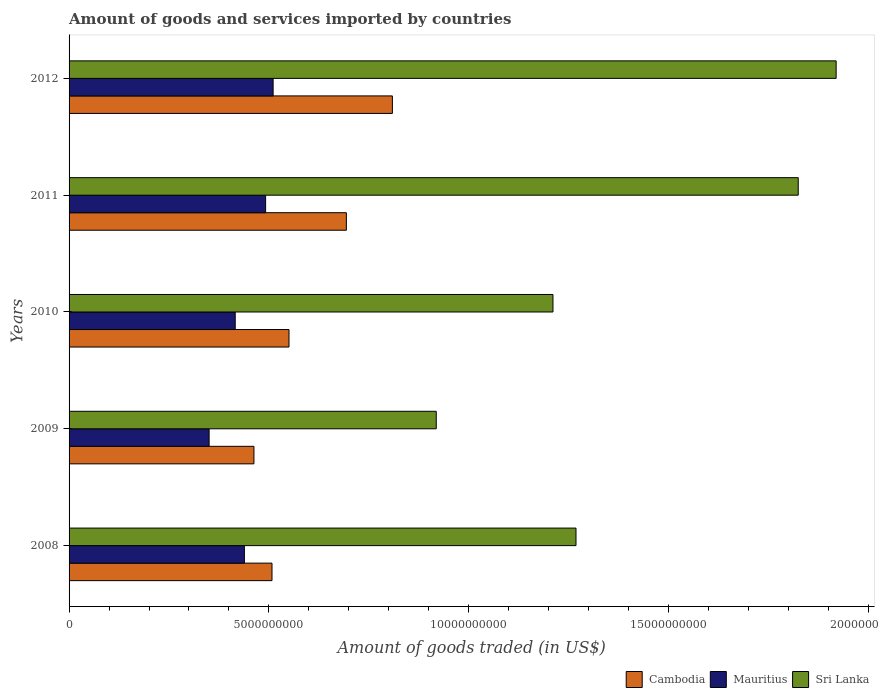How many different coloured bars are there?
Your answer should be very brief. 3. How many groups of bars are there?
Ensure brevity in your answer.  5. Are the number of bars per tick equal to the number of legend labels?
Provide a short and direct response. Yes. How many bars are there on the 5th tick from the bottom?
Keep it short and to the point. 3. What is the label of the 4th group of bars from the top?
Offer a terse response. 2009. What is the total amount of goods and services imported in Cambodia in 2012?
Provide a short and direct response. 8.09e+09. Across all years, what is the maximum total amount of goods and services imported in Mauritius?
Give a very brief answer. 5.10e+09. Across all years, what is the minimum total amount of goods and services imported in Sri Lanka?
Offer a terse response. 9.19e+09. In which year was the total amount of goods and services imported in Sri Lanka maximum?
Ensure brevity in your answer.  2012. What is the total total amount of goods and services imported in Sri Lanka in the graph?
Provide a succinct answer. 7.14e+1. What is the difference between the total amount of goods and services imported in Mauritius in 2009 and that in 2012?
Offer a terse response. -1.60e+09. What is the difference between the total amount of goods and services imported in Cambodia in 2009 and the total amount of goods and services imported in Mauritius in 2011?
Ensure brevity in your answer.  -2.93e+08. What is the average total amount of goods and services imported in Cambodia per year?
Make the answer very short. 6.05e+09. In the year 2011, what is the difference between the total amount of goods and services imported in Cambodia and total amount of goods and services imported in Mauritius?
Keep it short and to the point. 2.02e+09. In how many years, is the total amount of goods and services imported in Sri Lanka greater than 18000000000 US$?
Provide a short and direct response. 2. What is the ratio of the total amount of goods and services imported in Sri Lanka in 2011 to that in 2012?
Your answer should be very brief. 0.95. Is the total amount of goods and services imported in Sri Lanka in 2010 less than that in 2011?
Your response must be concise. Yes. What is the difference between the highest and the second highest total amount of goods and services imported in Mauritius?
Give a very brief answer. 1.87e+08. What is the difference between the highest and the lowest total amount of goods and services imported in Cambodia?
Make the answer very short. 3.46e+09. What does the 2nd bar from the top in 2008 represents?
Give a very brief answer. Mauritius. What does the 1st bar from the bottom in 2009 represents?
Provide a succinct answer. Cambodia. Is it the case that in every year, the sum of the total amount of goods and services imported in Mauritius and total amount of goods and services imported in Cambodia is greater than the total amount of goods and services imported in Sri Lanka?
Your response must be concise. No. How many bars are there?
Give a very brief answer. 15. How many years are there in the graph?
Provide a succinct answer. 5. Where does the legend appear in the graph?
Make the answer very short. Bottom right. How many legend labels are there?
Your answer should be compact. 3. How are the legend labels stacked?
Your answer should be compact. Horizontal. What is the title of the graph?
Your response must be concise. Amount of goods and services imported by countries. What is the label or title of the X-axis?
Ensure brevity in your answer.  Amount of goods traded (in US$). What is the Amount of goods traded (in US$) of Cambodia in 2008?
Provide a succinct answer. 5.08e+09. What is the Amount of goods traded (in US$) in Mauritius in 2008?
Your answer should be compact. 4.39e+09. What is the Amount of goods traded (in US$) of Sri Lanka in 2008?
Keep it short and to the point. 1.27e+1. What is the Amount of goods traded (in US$) of Cambodia in 2009?
Give a very brief answer. 4.62e+09. What is the Amount of goods traded (in US$) of Mauritius in 2009?
Provide a succinct answer. 3.50e+09. What is the Amount of goods traded (in US$) in Sri Lanka in 2009?
Provide a succinct answer. 9.19e+09. What is the Amount of goods traded (in US$) in Cambodia in 2010?
Make the answer very short. 5.50e+09. What is the Amount of goods traded (in US$) of Mauritius in 2010?
Give a very brief answer. 4.16e+09. What is the Amount of goods traded (in US$) in Sri Lanka in 2010?
Your answer should be very brief. 1.21e+1. What is the Amount of goods traded (in US$) in Cambodia in 2011?
Keep it short and to the point. 6.94e+09. What is the Amount of goods traded (in US$) of Mauritius in 2011?
Keep it short and to the point. 4.92e+09. What is the Amount of goods traded (in US$) of Sri Lanka in 2011?
Your answer should be very brief. 1.82e+1. What is the Amount of goods traded (in US$) of Cambodia in 2012?
Give a very brief answer. 8.09e+09. What is the Amount of goods traded (in US$) of Mauritius in 2012?
Keep it short and to the point. 5.10e+09. What is the Amount of goods traded (in US$) in Sri Lanka in 2012?
Your response must be concise. 1.92e+1. Across all years, what is the maximum Amount of goods traded (in US$) in Cambodia?
Offer a very short reply. 8.09e+09. Across all years, what is the maximum Amount of goods traded (in US$) of Mauritius?
Provide a succinct answer. 5.10e+09. Across all years, what is the maximum Amount of goods traded (in US$) of Sri Lanka?
Make the answer very short. 1.92e+1. Across all years, what is the minimum Amount of goods traded (in US$) in Cambodia?
Offer a very short reply. 4.62e+09. Across all years, what is the minimum Amount of goods traded (in US$) of Mauritius?
Your response must be concise. 3.50e+09. Across all years, what is the minimum Amount of goods traded (in US$) in Sri Lanka?
Your response must be concise. 9.19e+09. What is the total Amount of goods traded (in US$) in Cambodia in the graph?
Provide a succinct answer. 3.02e+1. What is the total Amount of goods traded (in US$) in Mauritius in the graph?
Offer a terse response. 2.21e+1. What is the total Amount of goods traded (in US$) of Sri Lanka in the graph?
Keep it short and to the point. 7.14e+1. What is the difference between the Amount of goods traded (in US$) of Cambodia in 2008 and that in 2009?
Your response must be concise. 4.52e+08. What is the difference between the Amount of goods traded (in US$) in Mauritius in 2008 and that in 2009?
Your response must be concise. 8.82e+08. What is the difference between the Amount of goods traded (in US$) in Sri Lanka in 2008 and that in 2009?
Ensure brevity in your answer.  3.50e+09. What is the difference between the Amount of goods traded (in US$) in Cambodia in 2008 and that in 2010?
Keep it short and to the point. -4.25e+08. What is the difference between the Amount of goods traded (in US$) of Mauritius in 2008 and that in 2010?
Provide a short and direct response. 2.29e+08. What is the difference between the Amount of goods traded (in US$) in Sri Lanka in 2008 and that in 2010?
Give a very brief answer. 5.76e+08. What is the difference between the Amount of goods traded (in US$) in Cambodia in 2008 and that in 2011?
Ensure brevity in your answer.  -1.86e+09. What is the difference between the Amount of goods traded (in US$) of Mauritius in 2008 and that in 2011?
Provide a short and direct response. -5.31e+08. What is the difference between the Amount of goods traded (in US$) of Sri Lanka in 2008 and that in 2011?
Your answer should be very brief. -5.56e+09. What is the difference between the Amount of goods traded (in US$) in Cambodia in 2008 and that in 2012?
Your answer should be very brief. -3.01e+09. What is the difference between the Amount of goods traded (in US$) in Mauritius in 2008 and that in 2012?
Make the answer very short. -7.19e+08. What is the difference between the Amount of goods traded (in US$) in Sri Lanka in 2008 and that in 2012?
Make the answer very short. -6.51e+09. What is the difference between the Amount of goods traded (in US$) in Cambodia in 2009 and that in 2010?
Provide a succinct answer. -8.77e+08. What is the difference between the Amount of goods traded (in US$) in Mauritius in 2009 and that in 2010?
Offer a very short reply. -6.53e+08. What is the difference between the Amount of goods traded (in US$) of Sri Lanka in 2009 and that in 2010?
Provide a short and direct response. -2.92e+09. What is the difference between the Amount of goods traded (in US$) in Cambodia in 2009 and that in 2011?
Provide a succinct answer. -2.31e+09. What is the difference between the Amount of goods traded (in US$) in Mauritius in 2009 and that in 2011?
Offer a very short reply. -1.41e+09. What is the difference between the Amount of goods traded (in US$) of Sri Lanka in 2009 and that in 2011?
Offer a terse response. -9.06e+09. What is the difference between the Amount of goods traded (in US$) in Cambodia in 2009 and that in 2012?
Offer a terse response. -3.46e+09. What is the difference between the Amount of goods traded (in US$) of Mauritius in 2009 and that in 2012?
Offer a very short reply. -1.60e+09. What is the difference between the Amount of goods traded (in US$) in Sri Lanka in 2009 and that in 2012?
Your answer should be very brief. -1.00e+1. What is the difference between the Amount of goods traded (in US$) in Cambodia in 2010 and that in 2011?
Your response must be concise. -1.44e+09. What is the difference between the Amount of goods traded (in US$) in Mauritius in 2010 and that in 2011?
Your answer should be compact. -7.61e+08. What is the difference between the Amount of goods traded (in US$) in Sri Lanka in 2010 and that in 2011?
Give a very brief answer. -6.14e+09. What is the difference between the Amount of goods traded (in US$) of Cambodia in 2010 and that in 2012?
Give a very brief answer. -2.59e+09. What is the difference between the Amount of goods traded (in US$) in Mauritius in 2010 and that in 2012?
Your response must be concise. -9.48e+08. What is the difference between the Amount of goods traded (in US$) of Sri Lanka in 2010 and that in 2012?
Offer a terse response. -7.08e+09. What is the difference between the Amount of goods traded (in US$) in Cambodia in 2011 and that in 2012?
Offer a terse response. -1.15e+09. What is the difference between the Amount of goods traded (in US$) in Mauritius in 2011 and that in 2012?
Provide a succinct answer. -1.87e+08. What is the difference between the Amount of goods traded (in US$) of Sri Lanka in 2011 and that in 2012?
Provide a short and direct response. -9.48e+08. What is the difference between the Amount of goods traded (in US$) in Cambodia in 2008 and the Amount of goods traded (in US$) in Mauritius in 2009?
Make the answer very short. 1.57e+09. What is the difference between the Amount of goods traded (in US$) of Cambodia in 2008 and the Amount of goods traded (in US$) of Sri Lanka in 2009?
Ensure brevity in your answer.  -4.11e+09. What is the difference between the Amount of goods traded (in US$) in Mauritius in 2008 and the Amount of goods traded (in US$) in Sri Lanka in 2009?
Provide a short and direct response. -4.80e+09. What is the difference between the Amount of goods traded (in US$) of Cambodia in 2008 and the Amount of goods traded (in US$) of Mauritius in 2010?
Your answer should be compact. 9.20e+08. What is the difference between the Amount of goods traded (in US$) of Cambodia in 2008 and the Amount of goods traded (in US$) of Sri Lanka in 2010?
Make the answer very short. -7.03e+09. What is the difference between the Amount of goods traded (in US$) in Mauritius in 2008 and the Amount of goods traded (in US$) in Sri Lanka in 2010?
Give a very brief answer. -7.72e+09. What is the difference between the Amount of goods traded (in US$) in Cambodia in 2008 and the Amount of goods traded (in US$) in Mauritius in 2011?
Your answer should be compact. 1.59e+08. What is the difference between the Amount of goods traded (in US$) in Cambodia in 2008 and the Amount of goods traded (in US$) in Sri Lanka in 2011?
Keep it short and to the point. -1.32e+1. What is the difference between the Amount of goods traded (in US$) in Mauritius in 2008 and the Amount of goods traded (in US$) in Sri Lanka in 2011?
Provide a short and direct response. -1.39e+1. What is the difference between the Amount of goods traded (in US$) in Cambodia in 2008 and the Amount of goods traded (in US$) in Mauritius in 2012?
Provide a short and direct response. -2.81e+07. What is the difference between the Amount of goods traded (in US$) in Cambodia in 2008 and the Amount of goods traded (in US$) in Sri Lanka in 2012?
Your response must be concise. -1.41e+1. What is the difference between the Amount of goods traded (in US$) in Mauritius in 2008 and the Amount of goods traded (in US$) in Sri Lanka in 2012?
Ensure brevity in your answer.  -1.48e+1. What is the difference between the Amount of goods traded (in US$) in Cambodia in 2009 and the Amount of goods traded (in US$) in Mauritius in 2010?
Ensure brevity in your answer.  4.68e+08. What is the difference between the Amount of goods traded (in US$) in Cambodia in 2009 and the Amount of goods traded (in US$) in Sri Lanka in 2010?
Your response must be concise. -7.48e+09. What is the difference between the Amount of goods traded (in US$) of Mauritius in 2009 and the Amount of goods traded (in US$) of Sri Lanka in 2010?
Your response must be concise. -8.60e+09. What is the difference between the Amount of goods traded (in US$) in Cambodia in 2009 and the Amount of goods traded (in US$) in Mauritius in 2011?
Give a very brief answer. -2.93e+08. What is the difference between the Amount of goods traded (in US$) of Cambodia in 2009 and the Amount of goods traded (in US$) of Sri Lanka in 2011?
Your response must be concise. -1.36e+1. What is the difference between the Amount of goods traded (in US$) in Mauritius in 2009 and the Amount of goods traded (in US$) in Sri Lanka in 2011?
Your response must be concise. -1.47e+1. What is the difference between the Amount of goods traded (in US$) in Cambodia in 2009 and the Amount of goods traded (in US$) in Mauritius in 2012?
Offer a very short reply. -4.80e+08. What is the difference between the Amount of goods traded (in US$) in Cambodia in 2009 and the Amount of goods traded (in US$) in Sri Lanka in 2012?
Offer a terse response. -1.46e+1. What is the difference between the Amount of goods traded (in US$) in Mauritius in 2009 and the Amount of goods traded (in US$) in Sri Lanka in 2012?
Offer a terse response. -1.57e+1. What is the difference between the Amount of goods traded (in US$) in Cambodia in 2010 and the Amount of goods traded (in US$) in Mauritius in 2011?
Offer a terse response. 5.85e+08. What is the difference between the Amount of goods traded (in US$) in Cambodia in 2010 and the Amount of goods traded (in US$) in Sri Lanka in 2011?
Give a very brief answer. -1.27e+1. What is the difference between the Amount of goods traded (in US$) in Mauritius in 2010 and the Amount of goods traded (in US$) in Sri Lanka in 2011?
Your answer should be very brief. -1.41e+1. What is the difference between the Amount of goods traded (in US$) of Cambodia in 2010 and the Amount of goods traded (in US$) of Mauritius in 2012?
Keep it short and to the point. 3.97e+08. What is the difference between the Amount of goods traded (in US$) of Cambodia in 2010 and the Amount of goods traded (in US$) of Sri Lanka in 2012?
Your response must be concise. -1.37e+1. What is the difference between the Amount of goods traded (in US$) in Mauritius in 2010 and the Amount of goods traded (in US$) in Sri Lanka in 2012?
Your answer should be very brief. -1.50e+1. What is the difference between the Amount of goods traded (in US$) of Cambodia in 2011 and the Amount of goods traded (in US$) of Mauritius in 2012?
Your answer should be very brief. 1.83e+09. What is the difference between the Amount of goods traded (in US$) of Cambodia in 2011 and the Amount of goods traded (in US$) of Sri Lanka in 2012?
Ensure brevity in your answer.  -1.23e+1. What is the difference between the Amount of goods traded (in US$) in Mauritius in 2011 and the Amount of goods traded (in US$) in Sri Lanka in 2012?
Offer a terse response. -1.43e+1. What is the average Amount of goods traded (in US$) in Cambodia per year?
Keep it short and to the point. 6.05e+09. What is the average Amount of goods traded (in US$) in Mauritius per year?
Make the answer very short. 4.41e+09. What is the average Amount of goods traded (in US$) of Sri Lanka per year?
Give a very brief answer. 1.43e+1. In the year 2008, what is the difference between the Amount of goods traded (in US$) of Cambodia and Amount of goods traded (in US$) of Mauritius?
Offer a terse response. 6.91e+08. In the year 2008, what is the difference between the Amount of goods traded (in US$) in Cambodia and Amount of goods traded (in US$) in Sri Lanka?
Keep it short and to the point. -7.61e+09. In the year 2008, what is the difference between the Amount of goods traded (in US$) of Mauritius and Amount of goods traded (in US$) of Sri Lanka?
Keep it short and to the point. -8.30e+09. In the year 2009, what is the difference between the Amount of goods traded (in US$) in Cambodia and Amount of goods traded (in US$) in Mauritius?
Your answer should be very brief. 1.12e+09. In the year 2009, what is the difference between the Amount of goods traded (in US$) in Cambodia and Amount of goods traded (in US$) in Sri Lanka?
Your answer should be very brief. -4.56e+09. In the year 2009, what is the difference between the Amount of goods traded (in US$) in Mauritius and Amount of goods traded (in US$) in Sri Lanka?
Provide a short and direct response. -5.68e+09. In the year 2010, what is the difference between the Amount of goods traded (in US$) in Cambodia and Amount of goods traded (in US$) in Mauritius?
Your answer should be compact. 1.35e+09. In the year 2010, what is the difference between the Amount of goods traded (in US$) in Cambodia and Amount of goods traded (in US$) in Sri Lanka?
Your answer should be very brief. -6.60e+09. In the year 2010, what is the difference between the Amount of goods traded (in US$) in Mauritius and Amount of goods traded (in US$) in Sri Lanka?
Provide a succinct answer. -7.95e+09. In the year 2011, what is the difference between the Amount of goods traded (in US$) in Cambodia and Amount of goods traded (in US$) in Mauritius?
Your answer should be very brief. 2.02e+09. In the year 2011, what is the difference between the Amount of goods traded (in US$) of Cambodia and Amount of goods traded (in US$) of Sri Lanka?
Provide a short and direct response. -1.13e+1. In the year 2011, what is the difference between the Amount of goods traded (in US$) of Mauritius and Amount of goods traded (in US$) of Sri Lanka?
Make the answer very short. -1.33e+1. In the year 2012, what is the difference between the Amount of goods traded (in US$) in Cambodia and Amount of goods traded (in US$) in Mauritius?
Make the answer very short. 2.98e+09. In the year 2012, what is the difference between the Amount of goods traded (in US$) of Cambodia and Amount of goods traded (in US$) of Sri Lanka?
Give a very brief answer. -1.11e+1. In the year 2012, what is the difference between the Amount of goods traded (in US$) in Mauritius and Amount of goods traded (in US$) in Sri Lanka?
Offer a very short reply. -1.41e+1. What is the ratio of the Amount of goods traded (in US$) of Cambodia in 2008 to that in 2009?
Ensure brevity in your answer.  1.1. What is the ratio of the Amount of goods traded (in US$) in Mauritius in 2008 to that in 2009?
Ensure brevity in your answer.  1.25. What is the ratio of the Amount of goods traded (in US$) of Sri Lanka in 2008 to that in 2009?
Provide a succinct answer. 1.38. What is the ratio of the Amount of goods traded (in US$) in Cambodia in 2008 to that in 2010?
Keep it short and to the point. 0.92. What is the ratio of the Amount of goods traded (in US$) of Mauritius in 2008 to that in 2010?
Offer a very short reply. 1.06. What is the ratio of the Amount of goods traded (in US$) in Sri Lanka in 2008 to that in 2010?
Make the answer very short. 1.05. What is the ratio of the Amount of goods traded (in US$) in Cambodia in 2008 to that in 2011?
Your answer should be very brief. 0.73. What is the ratio of the Amount of goods traded (in US$) of Mauritius in 2008 to that in 2011?
Your response must be concise. 0.89. What is the ratio of the Amount of goods traded (in US$) of Sri Lanka in 2008 to that in 2011?
Your answer should be very brief. 0.7. What is the ratio of the Amount of goods traded (in US$) in Cambodia in 2008 to that in 2012?
Your answer should be very brief. 0.63. What is the ratio of the Amount of goods traded (in US$) in Mauritius in 2008 to that in 2012?
Offer a terse response. 0.86. What is the ratio of the Amount of goods traded (in US$) in Sri Lanka in 2008 to that in 2012?
Your response must be concise. 0.66. What is the ratio of the Amount of goods traded (in US$) in Cambodia in 2009 to that in 2010?
Your answer should be compact. 0.84. What is the ratio of the Amount of goods traded (in US$) in Mauritius in 2009 to that in 2010?
Provide a succinct answer. 0.84. What is the ratio of the Amount of goods traded (in US$) in Sri Lanka in 2009 to that in 2010?
Offer a terse response. 0.76. What is the ratio of the Amount of goods traded (in US$) in Mauritius in 2009 to that in 2011?
Your response must be concise. 0.71. What is the ratio of the Amount of goods traded (in US$) in Sri Lanka in 2009 to that in 2011?
Keep it short and to the point. 0.5. What is the ratio of the Amount of goods traded (in US$) in Cambodia in 2009 to that in 2012?
Offer a terse response. 0.57. What is the ratio of the Amount of goods traded (in US$) in Mauritius in 2009 to that in 2012?
Offer a terse response. 0.69. What is the ratio of the Amount of goods traded (in US$) in Sri Lanka in 2009 to that in 2012?
Your answer should be compact. 0.48. What is the ratio of the Amount of goods traded (in US$) in Cambodia in 2010 to that in 2011?
Offer a very short reply. 0.79. What is the ratio of the Amount of goods traded (in US$) of Mauritius in 2010 to that in 2011?
Your response must be concise. 0.85. What is the ratio of the Amount of goods traded (in US$) in Sri Lanka in 2010 to that in 2011?
Your answer should be compact. 0.66. What is the ratio of the Amount of goods traded (in US$) of Cambodia in 2010 to that in 2012?
Provide a succinct answer. 0.68. What is the ratio of the Amount of goods traded (in US$) of Mauritius in 2010 to that in 2012?
Provide a short and direct response. 0.81. What is the ratio of the Amount of goods traded (in US$) of Sri Lanka in 2010 to that in 2012?
Provide a short and direct response. 0.63. What is the ratio of the Amount of goods traded (in US$) of Cambodia in 2011 to that in 2012?
Your answer should be very brief. 0.86. What is the ratio of the Amount of goods traded (in US$) in Mauritius in 2011 to that in 2012?
Offer a terse response. 0.96. What is the ratio of the Amount of goods traded (in US$) of Sri Lanka in 2011 to that in 2012?
Make the answer very short. 0.95. What is the difference between the highest and the second highest Amount of goods traded (in US$) of Cambodia?
Give a very brief answer. 1.15e+09. What is the difference between the highest and the second highest Amount of goods traded (in US$) in Mauritius?
Your answer should be compact. 1.87e+08. What is the difference between the highest and the second highest Amount of goods traded (in US$) in Sri Lanka?
Your answer should be very brief. 9.48e+08. What is the difference between the highest and the lowest Amount of goods traded (in US$) of Cambodia?
Offer a very short reply. 3.46e+09. What is the difference between the highest and the lowest Amount of goods traded (in US$) of Mauritius?
Offer a very short reply. 1.60e+09. What is the difference between the highest and the lowest Amount of goods traded (in US$) of Sri Lanka?
Make the answer very short. 1.00e+1. 